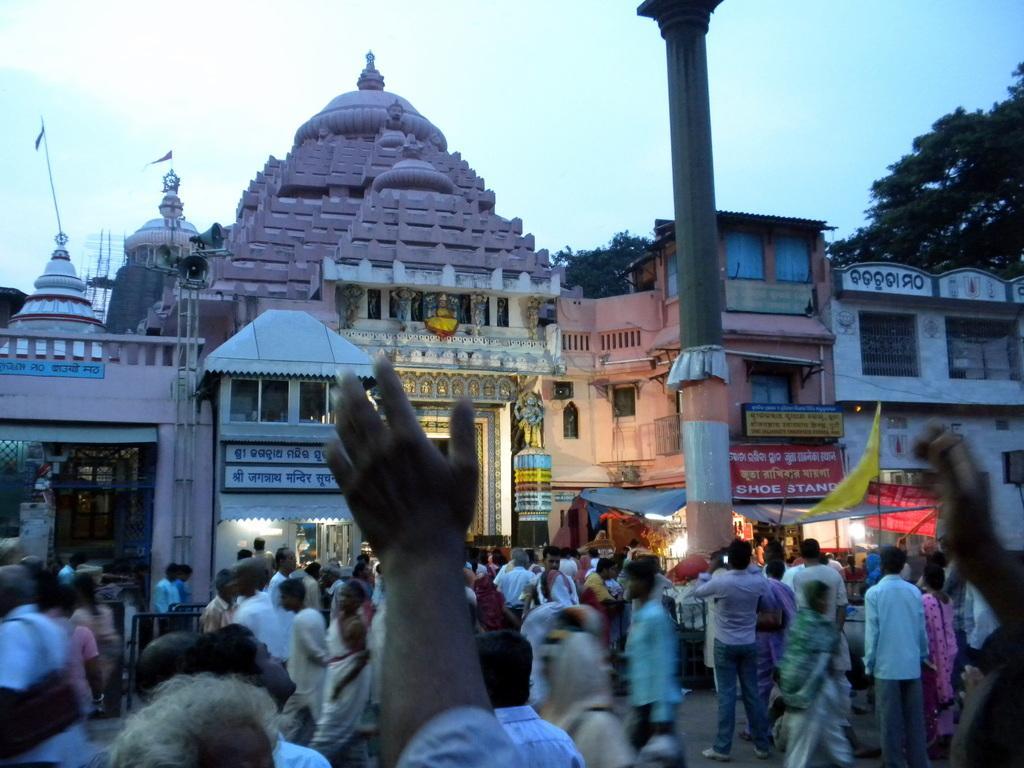Describe this image in one or two sentences. In this picture I can see buildings and few people standing and few are walking and I can see a flag and few trees and a cloudy sky and I can see couple of flags on the building and a metal pole and I can see text on the boards. 